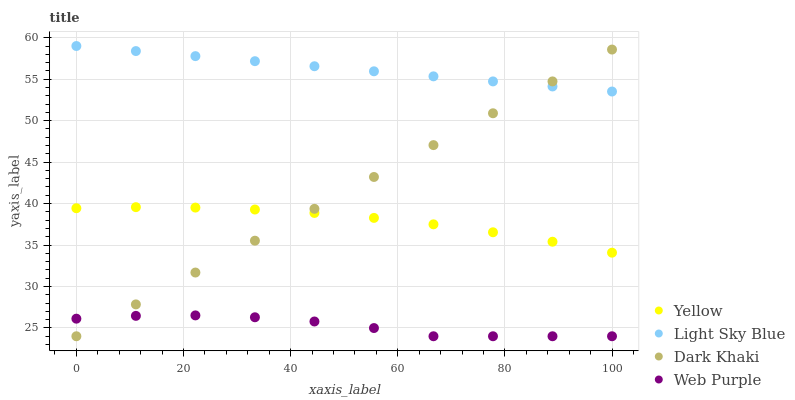Does Web Purple have the minimum area under the curve?
Answer yes or no. Yes. Does Light Sky Blue have the maximum area under the curve?
Answer yes or no. Yes. Does Light Sky Blue have the minimum area under the curve?
Answer yes or no. No. Does Web Purple have the maximum area under the curve?
Answer yes or no. No. Is Light Sky Blue the smoothest?
Answer yes or no. Yes. Is Web Purple the roughest?
Answer yes or no. Yes. Is Web Purple the smoothest?
Answer yes or no. No. Is Light Sky Blue the roughest?
Answer yes or no. No. Does Dark Khaki have the lowest value?
Answer yes or no. Yes. Does Light Sky Blue have the lowest value?
Answer yes or no. No. Does Light Sky Blue have the highest value?
Answer yes or no. Yes. Does Web Purple have the highest value?
Answer yes or no. No. Is Yellow less than Light Sky Blue?
Answer yes or no. Yes. Is Light Sky Blue greater than Yellow?
Answer yes or no. Yes. Does Dark Khaki intersect Light Sky Blue?
Answer yes or no. Yes. Is Dark Khaki less than Light Sky Blue?
Answer yes or no. No. Is Dark Khaki greater than Light Sky Blue?
Answer yes or no. No. Does Yellow intersect Light Sky Blue?
Answer yes or no. No. 